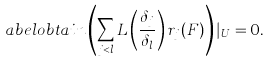Convert formula to latex. <formula><loc_0><loc_0><loc_500><loc_500>\L a b e l { o b t a i n } \left ( \sum _ { j < l } L \left ( \frac { \delta _ { j } } { \delta _ { l } } \right ) r _ { j } ( F ) \right ) | _ { U } = 0 .</formula> 